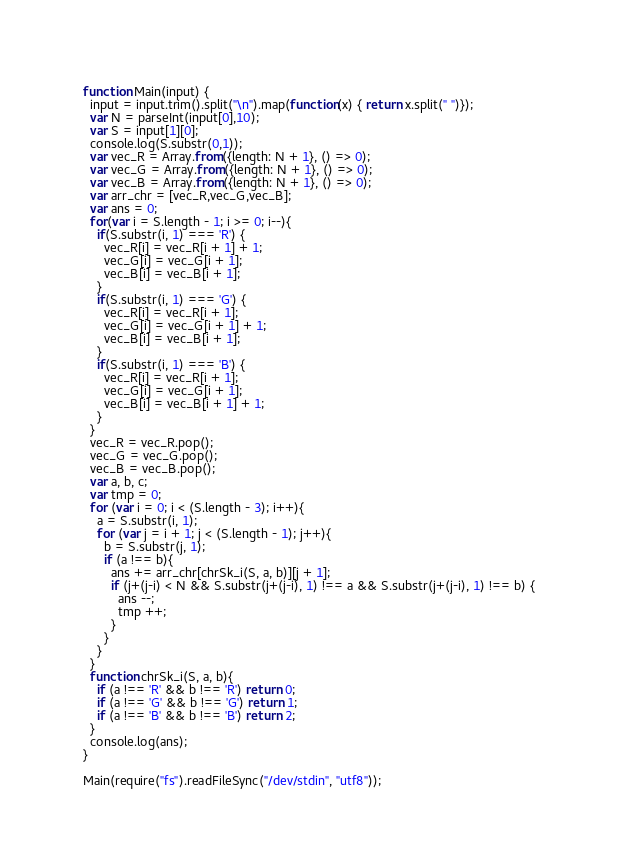<code> <loc_0><loc_0><loc_500><loc_500><_JavaScript_>function Main(input) {
  input = input.trim().split("\n").map(function(x) { return x.split(" ")});
  var N = parseInt(input[0],10);
  var S = input[1][0];
  console.log(S.substr(0,1));
  var vec_R = Array.from({length: N + 1}, () => 0);
  var vec_G = Array.from({length: N + 1}, () => 0);
  var vec_B = Array.from({length: N + 1}, () => 0);
  var arr_chr = [vec_R,vec_G,vec_B];
  var ans = 0;
  for(var i = S.length - 1; i >= 0; i--){
    if(S.substr(i, 1) === 'R') {
      vec_R[i] = vec_R[i + 1] + 1;
      vec_G[i] = vec_G[i + 1];
      vec_B[i] = vec_B[i + 1]; 
    }
    if(S.substr(i, 1) === 'G') {
      vec_R[i] = vec_R[i + 1];
      vec_G[i] = vec_G[i + 1] + 1;
      vec_B[i] = vec_B[i + 1];
    }
    if(S.substr(i, 1) === 'B') {
      vec_R[i] = vec_R[i + 1];
      vec_G[i] = vec_G[i + 1];
      vec_B[i] = vec_B[i + 1] + 1;
    }
  }
  vec_R = vec_R.pop();
  vec_G = vec_G.pop();
  vec_B = vec_B.pop();
  var a, b, c;
  var tmp = 0;
  for (var i = 0; i < (S.length - 3); i++){
    a = S.substr(i, 1);
    for (var j = i + 1; j < (S.length - 1); j++){
      b = S.substr(j, 1);
      if (a !== b){
        ans += arr_chr[chrSk_i(S, a, b)][j + 1];
        if (j+(j-i) < N && S.substr(j+(j-i), 1) !== a && S.substr(j+(j-i), 1) !== b) {
          ans --;
          tmp ++;
        }
      }
    }
  }
  function chrSk_i(S, a, b){
    if (a !== 'R' && b !== 'R') return 0;
    if (a !== 'G' && b !== 'G') return 1;
    if (a !== 'B' && b !== 'B') return 2;
  }
  console.log(ans);
}   

Main(require("fs").readFileSync("/dev/stdin", "utf8"));</code> 